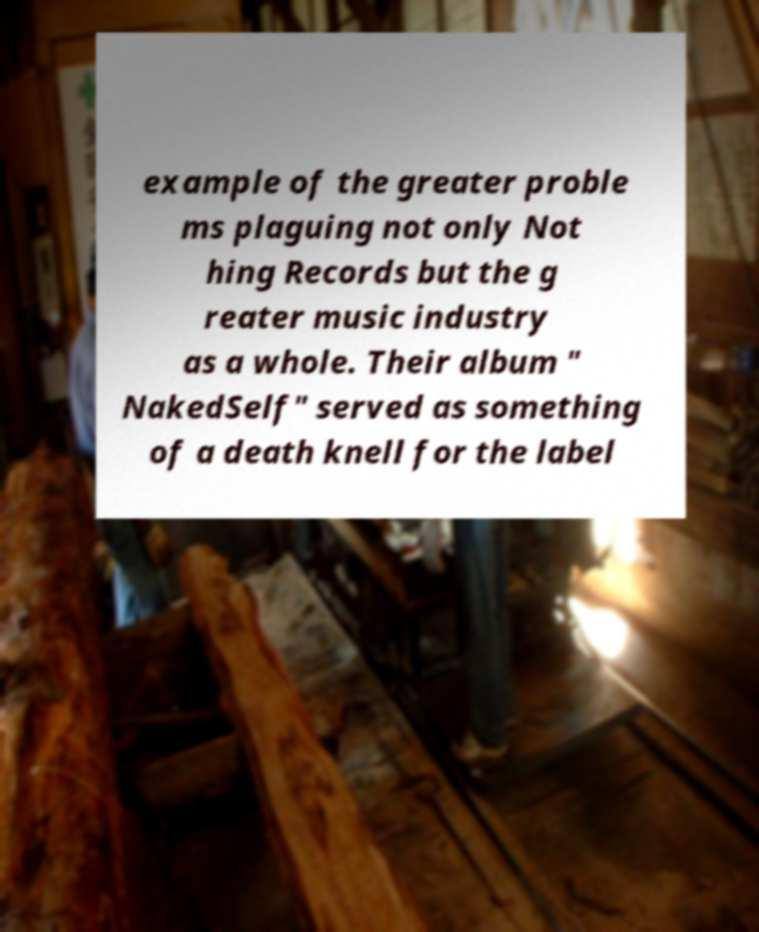What messages or text are displayed in this image? I need them in a readable, typed format. example of the greater proble ms plaguing not only Not hing Records but the g reater music industry as a whole. Their album " NakedSelf" served as something of a death knell for the label 